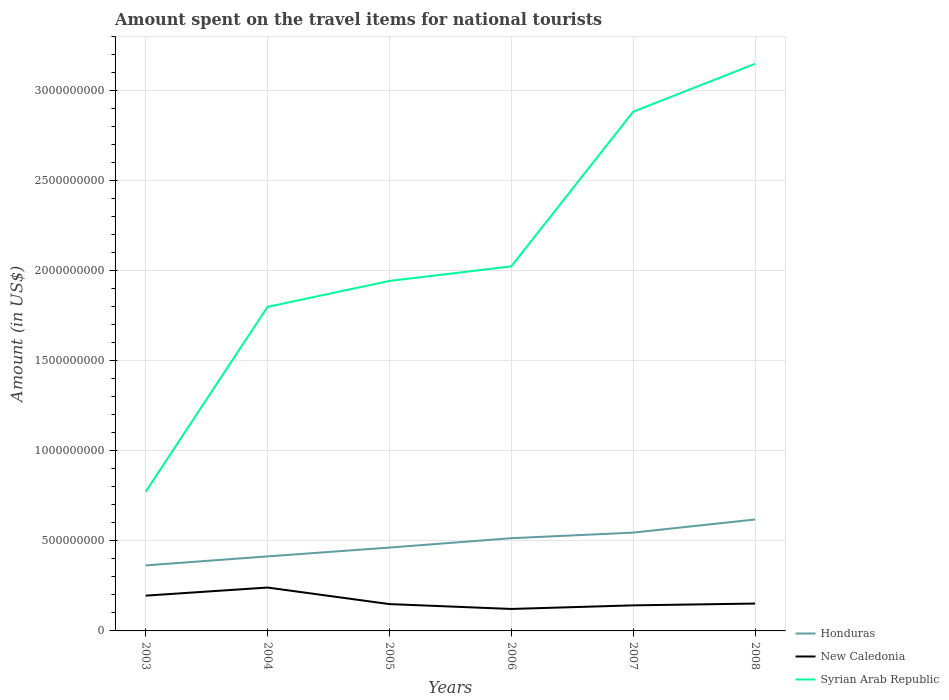Does the line corresponding to Syrian Arab Republic intersect with the line corresponding to Honduras?
Make the answer very short. No. Across all years, what is the maximum amount spent on the travel items for national tourists in Syrian Arab Republic?
Your answer should be very brief. 7.73e+08. What is the total amount spent on the travel items for national tourists in Syrian Arab Republic in the graph?
Provide a succinct answer. -1.44e+08. What is the difference between the highest and the second highest amount spent on the travel items for national tourists in New Caledonia?
Provide a short and direct response. 1.19e+08. What is the difference between the highest and the lowest amount spent on the travel items for national tourists in Syrian Arab Republic?
Your response must be concise. 2. How many years are there in the graph?
Your answer should be compact. 6. Where does the legend appear in the graph?
Offer a very short reply. Bottom right. How are the legend labels stacked?
Make the answer very short. Vertical. What is the title of the graph?
Offer a very short reply. Amount spent on the travel items for national tourists. What is the label or title of the Y-axis?
Provide a short and direct response. Amount (in US$). What is the Amount (in US$) in Honduras in 2003?
Give a very brief answer. 3.64e+08. What is the Amount (in US$) in New Caledonia in 2003?
Offer a very short reply. 1.96e+08. What is the Amount (in US$) in Syrian Arab Republic in 2003?
Give a very brief answer. 7.73e+08. What is the Amount (in US$) in Honduras in 2004?
Keep it short and to the point. 4.14e+08. What is the Amount (in US$) of New Caledonia in 2004?
Provide a short and direct response. 2.41e+08. What is the Amount (in US$) of Syrian Arab Republic in 2004?
Offer a very short reply. 1.80e+09. What is the Amount (in US$) in Honduras in 2005?
Your response must be concise. 4.63e+08. What is the Amount (in US$) in New Caledonia in 2005?
Provide a succinct answer. 1.49e+08. What is the Amount (in US$) in Syrian Arab Republic in 2005?
Provide a succinct answer. 1.94e+09. What is the Amount (in US$) of Honduras in 2006?
Make the answer very short. 5.15e+08. What is the Amount (in US$) in New Caledonia in 2006?
Your response must be concise. 1.22e+08. What is the Amount (in US$) of Syrian Arab Republic in 2006?
Your answer should be compact. 2.02e+09. What is the Amount (in US$) in Honduras in 2007?
Offer a very short reply. 5.46e+08. What is the Amount (in US$) in New Caledonia in 2007?
Ensure brevity in your answer.  1.42e+08. What is the Amount (in US$) of Syrian Arab Republic in 2007?
Give a very brief answer. 2.88e+09. What is the Amount (in US$) of Honduras in 2008?
Offer a very short reply. 6.19e+08. What is the Amount (in US$) in New Caledonia in 2008?
Provide a succinct answer. 1.52e+08. What is the Amount (in US$) in Syrian Arab Republic in 2008?
Keep it short and to the point. 3.15e+09. Across all years, what is the maximum Amount (in US$) in Honduras?
Keep it short and to the point. 6.19e+08. Across all years, what is the maximum Amount (in US$) of New Caledonia?
Keep it short and to the point. 2.41e+08. Across all years, what is the maximum Amount (in US$) of Syrian Arab Republic?
Keep it short and to the point. 3.15e+09. Across all years, what is the minimum Amount (in US$) of Honduras?
Your response must be concise. 3.64e+08. Across all years, what is the minimum Amount (in US$) of New Caledonia?
Make the answer very short. 1.22e+08. Across all years, what is the minimum Amount (in US$) in Syrian Arab Republic?
Your response must be concise. 7.73e+08. What is the total Amount (in US$) in Honduras in the graph?
Ensure brevity in your answer.  2.92e+09. What is the total Amount (in US$) of New Caledonia in the graph?
Give a very brief answer. 1.00e+09. What is the total Amount (in US$) of Syrian Arab Republic in the graph?
Offer a very short reply. 1.26e+1. What is the difference between the Amount (in US$) in Honduras in 2003 and that in 2004?
Make the answer very short. -5.00e+07. What is the difference between the Amount (in US$) in New Caledonia in 2003 and that in 2004?
Offer a terse response. -4.50e+07. What is the difference between the Amount (in US$) in Syrian Arab Republic in 2003 and that in 2004?
Make the answer very short. -1.03e+09. What is the difference between the Amount (in US$) in Honduras in 2003 and that in 2005?
Your answer should be compact. -9.90e+07. What is the difference between the Amount (in US$) in New Caledonia in 2003 and that in 2005?
Ensure brevity in your answer.  4.70e+07. What is the difference between the Amount (in US$) of Syrian Arab Republic in 2003 and that in 2005?
Give a very brief answer. -1.17e+09. What is the difference between the Amount (in US$) of Honduras in 2003 and that in 2006?
Make the answer very short. -1.51e+08. What is the difference between the Amount (in US$) in New Caledonia in 2003 and that in 2006?
Your answer should be compact. 7.40e+07. What is the difference between the Amount (in US$) of Syrian Arab Republic in 2003 and that in 2006?
Provide a succinct answer. -1.25e+09. What is the difference between the Amount (in US$) in Honduras in 2003 and that in 2007?
Ensure brevity in your answer.  -1.82e+08. What is the difference between the Amount (in US$) in New Caledonia in 2003 and that in 2007?
Your response must be concise. 5.40e+07. What is the difference between the Amount (in US$) in Syrian Arab Republic in 2003 and that in 2007?
Give a very brief answer. -2.11e+09. What is the difference between the Amount (in US$) of Honduras in 2003 and that in 2008?
Provide a short and direct response. -2.55e+08. What is the difference between the Amount (in US$) in New Caledonia in 2003 and that in 2008?
Your answer should be very brief. 4.40e+07. What is the difference between the Amount (in US$) in Syrian Arab Republic in 2003 and that in 2008?
Keep it short and to the point. -2.38e+09. What is the difference between the Amount (in US$) of Honduras in 2004 and that in 2005?
Ensure brevity in your answer.  -4.90e+07. What is the difference between the Amount (in US$) of New Caledonia in 2004 and that in 2005?
Your answer should be very brief. 9.20e+07. What is the difference between the Amount (in US$) of Syrian Arab Republic in 2004 and that in 2005?
Keep it short and to the point. -1.44e+08. What is the difference between the Amount (in US$) in Honduras in 2004 and that in 2006?
Your answer should be compact. -1.01e+08. What is the difference between the Amount (in US$) of New Caledonia in 2004 and that in 2006?
Offer a terse response. 1.19e+08. What is the difference between the Amount (in US$) in Syrian Arab Republic in 2004 and that in 2006?
Offer a very short reply. -2.25e+08. What is the difference between the Amount (in US$) of Honduras in 2004 and that in 2007?
Give a very brief answer. -1.32e+08. What is the difference between the Amount (in US$) of New Caledonia in 2004 and that in 2007?
Ensure brevity in your answer.  9.90e+07. What is the difference between the Amount (in US$) of Syrian Arab Republic in 2004 and that in 2007?
Ensure brevity in your answer.  -1.08e+09. What is the difference between the Amount (in US$) of Honduras in 2004 and that in 2008?
Offer a very short reply. -2.05e+08. What is the difference between the Amount (in US$) in New Caledonia in 2004 and that in 2008?
Your response must be concise. 8.90e+07. What is the difference between the Amount (in US$) of Syrian Arab Republic in 2004 and that in 2008?
Your answer should be very brief. -1.35e+09. What is the difference between the Amount (in US$) of Honduras in 2005 and that in 2006?
Your answer should be very brief. -5.20e+07. What is the difference between the Amount (in US$) of New Caledonia in 2005 and that in 2006?
Provide a short and direct response. 2.70e+07. What is the difference between the Amount (in US$) in Syrian Arab Republic in 2005 and that in 2006?
Your answer should be very brief. -8.10e+07. What is the difference between the Amount (in US$) in Honduras in 2005 and that in 2007?
Give a very brief answer. -8.30e+07. What is the difference between the Amount (in US$) of Syrian Arab Republic in 2005 and that in 2007?
Offer a terse response. -9.40e+08. What is the difference between the Amount (in US$) of Honduras in 2005 and that in 2008?
Provide a succinct answer. -1.56e+08. What is the difference between the Amount (in US$) in Syrian Arab Republic in 2005 and that in 2008?
Keep it short and to the point. -1.21e+09. What is the difference between the Amount (in US$) of Honduras in 2006 and that in 2007?
Offer a terse response. -3.10e+07. What is the difference between the Amount (in US$) of New Caledonia in 2006 and that in 2007?
Your answer should be very brief. -2.00e+07. What is the difference between the Amount (in US$) in Syrian Arab Republic in 2006 and that in 2007?
Make the answer very short. -8.59e+08. What is the difference between the Amount (in US$) in Honduras in 2006 and that in 2008?
Make the answer very short. -1.04e+08. What is the difference between the Amount (in US$) of New Caledonia in 2006 and that in 2008?
Offer a terse response. -3.00e+07. What is the difference between the Amount (in US$) of Syrian Arab Republic in 2006 and that in 2008?
Provide a succinct answer. -1.12e+09. What is the difference between the Amount (in US$) in Honduras in 2007 and that in 2008?
Give a very brief answer. -7.30e+07. What is the difference between the Amount (in US$) of New Caledonia in 2007 and that in 2008?
Offer a terse response. -1.00e+07. What is the difference between the Amount (in US$) in Syrian Arab Republic in 2007 and that in 2008?
Ensure brevity in your answer.  -2.66e+08. What is the difference between the Amount (in US$) of Honduras in 2003 and the Amount (in US$) of New Caledonia in 2004?
Your response must be concise. 1.23e+08. What is the difference between the Amount (in US$) in Honduras in 2003 and the Amount (in US$) in Syrian Arab Republic in 2004?
Ensure brevity in your answer.  -1.44e+09. What is the difference between the Amount (in US$) in New Caledonia in 2003 and the Amount (in US$) in Syrian Arab Republic in 2004?
Make the answer very short. -1.60e+09. What is the difference between the Amount (in US$) of Honduras in 2003 and the Amount (in US$) of New Caledonia in 2005?
Offer a terse response. 2.15e+08. What is the difference between the Amount (in US$) of Honduras in 2003 and the Amount (in US$) of Syrian Arab Republic in 2005?
Give a very brief answer. -1.58e+09. What is the difference between the Amount (in US$) in New Caledonia in 2003 and the Amount (in US$) in Syrian Arab Republic in 2005?
Make the answer very short. -1.75e+09. What is the difference between the Amount (in US$) in Honduras in 2003 and the Amount (in US$) in New Caledonia in 2006?
Your answer should be compact. 2.42e+08. What is the difference between the Amount (in US$) in Honduras in 2003 and the Amount (in US$) in Syrian Arab Republic in 2006?
Provide a succinct answer. -1.66e+09. What is the difference between the Amount (in US$) in New Caledonia in 2003 and the Amount (in US$) in Syrian Arab Republic in 2006?
Your answer should be compact. -1.83e+09. What is the difference between the Amount (in US$) in Honduras in 2003 and the Amount (in US$) in New Caledonia in 2007?
Offer a terse response. 2.22e+08. What is the difference between the Amount (in US$) of Honduras in 2003 and the Amount (in US$) of Syrian Arab Republic in 2007?
Offer a terse response. -2.52e+09. What is the difference between the Amount (in US$) in New Caledonia in 2003 and the Amount (in US$) in Syrian Arab Republic in 2007?
Give a very brief answer. -2.69e+09. What is the difference between the Amount (in US$) in Honduras in 2003 and the Amount (in US$) in New Caledonia in 2008?
Your answer should be compact. 2.12e+08. What is the difference between the Amount (in US$) in Honduras in 2003 and the Amount (in US$) in Syrian Arab Republic in 2008?
Keep it short and to the point. -2.79e+09. What is the difference between the Amount (in US$) in New Caledonia in 2003 and the Amount (in US$) in Syrian Arab Republic in 2008?
Provide a short and direct response. -2.95e+09. What is the difference between the Amount (in US$) of Honduras in 2004 and the Amount (in US$) of New Caledonia in 2005?
Provide a succinct answer. 2.65e+08. What is the difference between the Amount (in US$) in Honduras in 2004 and the Amount (in US$) in Syrian Arab Republic in 2005?
Your answer should be compact. -1.53e+09. What is the difference between the Amount (in US$) in New Caledonia in 2004 and the Amount (in US$) in Syrian Arab Republic in 2005?
Your response must be concise. -1.70e+09. What is the difference between the Amount (in US$) of Honduras in 2004 and the Amount (in US$) of New Caledonia in 2006?
Your response must be concise. 2.92e+08. What is the difference between the Amount (in US$) in Honduras in 2004 and the Amount (in US$) in Syrian Arab Republic in 2006?
Ensure brevity in your answer.  -1.61e+09. What is the difference between the Amount (in US$) of New Caledonia in 2004 and the Amount (in US$) of Syrian Arab Republic in 2006?
Provide a short and direct response. -1.78e+09. What is the difference between the Amount (in US$) of Honduras in 2004 and the Amount (in US$) of New Caledonia in 2007?
Make the answer very short. 2.72e+08. What is the difference between the Amount (in US$) of Honduras in 2004 and the Amount (in US$) of Syrian Arab Republic in 2007?
Your response must be concise. -2.47e+09. What is the difference between the Amount (in US$) in New Caledonia in 2004 and the Amount (in US$) in Syrian Arab Republic in 2007?
Your answer should be very brief. -2.64e+09. What is the difference between the Amount (in US$) of Honduras in 2004 and the Amount (in US$) of New Caledonia in 2008?
Provide a short and direct response. 2.62e+08. What is the difference between the Amount (in US$) in Honduras in 2004 and the Amount (in US$) in Syrian Arab Republic in 2008?
Your answer should be very brief. -2.74e+09. What is the difference between the Amount (in US$) in New Caledonia in 2004 and the Amount (in US$) in Syrian Arab Republic in 2008?
Give a very brief answer. -2.91e+09. What is the difference between the Amount (in US$) in Honduras in 2005 and the Amount (in US$) in New Caledonia in 2006?
Ensure brevity in your answer.  3.41e+08. What is the difference between the Amount (in US$) in Honduras in 2005 and the Amount (in US$) in Syrian Arab Republic in 2006?
Give a very brief answer. -1.56e+09. What is the difference between the Amount (in US$) of New Caledonia in 2005 and the Amount (in US$) of Syrian Arab Republic in 2006?
Provide a succinct answer. -1.88e+09. What is the difference between the Amount (in US$) of Honduras in 2005 and the Amount (in US$) of New Caledonia in 2007?
Make the answer very short. 3.21e+08. What is the difference between the Amount (in US$) of Honduras in 2005 and the Amount (in US$) of Syrian Arab Republic in 2007?
Your answer should be very brief. -2.42e+09. What is the difference between the Amount (in US$) in New Caledonia in 2005 and the Amount (in US$) in Syrian Arab Republic in 2007?
Keep it short and to the point. -2.74e+09. What is the difference between the Amount (in US$) of Honduras in 2005 and the Amount (in US$) of New Caledonia in 2008?
Provide a succinct answer. 3.11e+08. What is the difference between the Amount (in US$) of Honduras in 2005 and the Amount (in US$) of Syrian Arab Republic in 2008?
Your answer should be compact. -2.69e+09. What is the difference between the Amount (in US$) in New Caledonia in 2005 and the Amount (in US$) in Syrian Arab Republic in 2008?
Provide a succinct answer. -3.00e+09. What is the difference between the Amount (in US$) of Honduras in 2006 and the Amount (in US$) of New Caledonia in 2007?
Your answer should be very brief. 3.73e+08. What is the difference between the Amount (in US$) of Honduras in 2006 and the Amount (in US$) of Syrian Arab Republic in 2007?
Offer a terse response. -2.37e+09. What is the difference between the Amount (in US$) of New Caledonia in 2006 and the Amount (in US$) of Syrian Arab Republic in 2007?
Your answer should be compact. -2.76e+09. What is the difference between the Amount (in US$) in Honduras in 2006 and the Amount (in US$) in New Caledonia in 2008?
Keep it short and to the point. 3.63e+08. What is the difference between the Amount (in US$) in Honduras in 2006 and the Amount (in US$) in Syrian Arab Republic in 2008?
Your response must be concise. -2.64e+09. What is the difference between the Amount (in US$) of New Caledonia in 2006 and the Amount (in US$) of Syrian Arab Republic in 2008?
Offer a terse response. -3.03e+09. What is the difference between the Amount (in US$) of Honduras in 2007 and the Amount (in US$) of New Caledonia in 2008?
Make the answer very short. 3.94e+08. What is the difference between the Amount (in US$) of Honduras in 2007 and the Amount (in US$) of Syrian Arab Republic in 2008?
Your response must be concise. -2.60e+09. What is the difference between the Amount (in US$) of New Caledonia in 2007 and the Amount (in US$) of Syrian Arab Republic in 2008?
Make the answer very short. -3.01e+09. What is the average Amount (in US$) of Honduras per year?
Make the answer very short. 4.87e+08. What is the average Amount (in US$) in New Caledonia per year?
Provide a short and direct response. 1.67e+08. What is the average Amount (in US$) in Syrian Arab Republic per year?
Provide a succinct answer. 2.10e+09. In the year 2003, what is the difference between the Amount (in US$) of Honduras and Amount (in US$) of New Caledonia?
Offer a terse response. 1.68e+08. In the year 2003, what is the difference between the Amount (in US$) in Honduras and Amount (in US$) in Syrian Arab Republic?
Make the answer very short. -4.09e+08. In the year 2003, what is the difference between the Amount (in US$) of New Caledonia and Amount (in US$) of Syrian Arab Republic?
Ensure brevity in your answer.  -5.77e+08. In the year 2004, what is the difference between the Amount (in US$) of Honduras and Amount (in US$) of New Caledonia?
Keep it short and to the point. 1.73e+08. In the year 2004, what is the difference between the Amount (in US$) in Honduras and Amount (in US$) in Syrian Arab Republic?
Provide a succinct answer. -1.39e+09. In the year 2004, what is the difference between the Amount (in US$) in New Caledonia and Amount (in US$) in Syrian Arab Republic?
Your answer should be very brief. -1.56e+09. In the year 2005, what is the difference between the Amount (in US$) of Honduras and Amount (in US$) of New Caledonia?
Your response must be concise. 3.14e+08. In the year 2005, what is the difference between the Amount (in US$) of Honduras and Amount (in US$) of Syrian Arab Republic?
Ensure brevity in your answer.  -1.48e+09. In the year 2005, what is the difference between the Amount (in US$) of New Caledonia and Amount (in US$) of Syrian Arab Republic?
Keep it short and to the point. -1.80e+09. In the year 2006, what is the difference between the Amount (in US$) of Honduras and Amount (in US$) of New Caledonia?
Your response must be concise. 3.93e+08. In the year 2006, what is the difference between the Amount (in US$) in Honduras and Amount (in US$) in Syrian Arab Republic?
Ensure brevity in your answer.  -1.51e+09. In the year 2006, what is the difference between the Amount (in US$) in New Caledonia and Amount (in US$) in Syrian Arab Republic?
Your answer should be very brief. -1.90e+09. In the year 2007, what is the difference between the Amount (in US$) in Honduras and Amount (in US$) in New Caledonia?
Your response must be concise. 4.04e+08. In the year 2007, what is the difference between the Amount (in US$) of Honduras and Amount (in US$) of Syrian Arab Republic?
Provide a short and direct response. -2.34e+09. In the year 2007, what is the difference between the Amount (in US$) in New Caledonia and Amount (in US$) in Syrian Arab Republic?
Provide a succinct answer. -2.74e+09. In the year 2008, what is the difference between the Amount (in US$) in Honduras and Amount (in US$) in New Caledonia?
Your response must be concise. 4.67e+08. In the year 2008, what is the difference between the Amount (in US$) in Honduras and Amount (in US$) in Syrian Arab Republic?
Provide a succinct answer. -2.53e+09. In the year 2008, what is the difference between the Amount (in US$) in New Caledonia and Amount (in US$) in Syrian Arab Republic?
Offer a terse response. -3.00e+09. What is the ratio of the Amount (in US$) in Honduras in 2003 to that in 2004?
Make the answer very short. 0.88. What is the ratio of the Amount (in US$) of New Caledonia in 2003 to that in 2004?
Your answer should be very brief. 0.81. What is the ratio of the Amount (in US$) of Syrian Arab Republic in 2003 to that in 2004?
Offer a terse response. 0.43. What is the ratio of the Amount (in US$) in Honduras in 2003 to that in 2005?
Provide a short and direct response. 0.79. What is the ratio of the Amount (in US$) of New Caledonia in 2003 to that in 2005?
Offer a very short reply. 1.32. What is the ratio of the Amount (in US$) in Syrian Arab Republic in 2003 to that in 2005?
Ensure brevity in your answer.  0.4. What is the ratio of the Amount (in US$) of Honduras in 2003 to that in 2006?
Ensure brevity in your answer.  0.71. What is the ratio of the Amount (in US$) in New Caledonia in 2003 to that in 2006?
Make the answer very short. 1.61. What is the ratio of the Amount (in US$) in Syrian Arab Republic in 2003 to that in 2006?
Ensure brevity in your answer.  0.38. What is the ratio of the Amount (in US$) in New Caledonia in 2003 to that in 2007?
Your answer should be compact. 1.38. What is the ratio of the Amount (in US$) in Syrian Arab Republic in 2003 to that in 2007?
Give a very brief answer. 0.27. What is the ratio of the Amount (in US$) in Honduras in 2003 to that in 2008?
Offer a very short reply. 0.59. What is the ratio of the Amount (in US$) in New Caledonia in 2003 to that in 2008?
Provide a succinct answer. 1.29. What is the ratio of the Amount (in US$) of Syrian Arab Republic in 2003 to that in 2008?
Your answer should be very brief. 0.25. What is the ratio of the Amount (in US$) of Honduras in 2004 to that in 2005?
Give a very brief answer. 0.89. What is the ratio of the Amount (in US$) in New Caledonia in 2004 to that in 2005?
Make the answer very short. 1.62. What is the ratio of the Amount (in US$) in Syrian Arab Republic in 2004 to that in 2005?
Give a very brief answer. 0.93. What is the ratio of the Amount (in US$) in Honduras in 2004 to that in 2006?
Ensure brevity in your answer.  0.8. What is the ratio of the Amount (in US$) in New Caledonia in 2004 to that in 2006?
Your answer should be very brief. 1.98. What is the ratio of the Amount (in US$) of Honduras in 2004 to that in 2007?
Keep it short and to the point. 0.76. What is the ratio of the Amount (in US$) of New Caledonia in 2004 to that in 2007?
Offer a very short reply. 1.7. What is the ratio of the Amount (in US$) in Syrian Arab Republic in 2004 to that in 2007?
Your response must be concise. 0.62. What is the ratio of the Amount (in US$) of Honduras in 2004 to that in 2008?
Your answer should be very brief. 0.67. What is the ratio of the Amount (in US$) of New Caledonia in 2004 to that in 2008?
Give a very brief answer. 1.59. What is the ratio of the Amount (in US$) in Syrian Arab Republic in 2004 to that in 2008?
Provide a short and direct response. 0.57. What is the ratio of the Amount (in US$) of Honduras in 2005 to that in 2006?
Provide a succinct answer. 0.9. What is the ratio of the Amount (in US$) of New Caledonia in 2005 to that in 2006?
Your answer should be compact. 1.22. What is the ratio of the Amount (in US$) of Syrian Arab Republic in 2005 to that in 2006?
Your answer should be compact. 0.96. What is the ratio of the Amount (in US$) in Honduras in 2005 to that in 2007?
Offer a terse response. 0.85. What is the ratio of the Amount (in US$) in New Caledonia in 2005 to that in 2007?
Provide a short and direct response. 1.05. What is the ratio of the Amount (in US$) of Syrian Arab Republic in 2005 to that in 2007?
Offer a terse response. 0.67. What is the ratio of the Amount (in US$) of Honduras in 2005 to that in 2008?
Ensure brevity in your answer.  0.75. What is the ratio of the Amount (in US$) of New Caledonia in 2005 to that in 2008?
Provide a short and direct response. 0.98. What is the ratio of the Amount (in US$) of Syrian Arab Republic in 2005 to that in 2008?
Provide a succinct answer. 0.62. What is the ratio of the Amount (in US$) in Honduras in 2006 to that in 2007?
Provide a short and direct response. 0.94. What is the ratio of the Amount (in US$) of New Caledonia in 2006 to that in 2007?
Offer a terse response. 0.86. What is the ratio of the Amount (in US$) of Syrian Arab Republic in 2006 to that in 2007?
Your answer should be very brief. 0.7. What is the ratio of the Amount (in US$) of Honduras in 2006 to that in 2008?
Provide a short and direct response. 0.83. What is the ratio of the Amount (in US$) of New Caledonia in 2006 to that in 2008?
Offer a terse response. 0.8. What is the ratio of the Amount (in US$) of Syrian Arab Republic in 2006 to that in 2008?
Your answer should be very brief. 0.64. What is the ratio of the Amount (in US$) of Honduras in 2007 to that in 2008?
Provide a succinct answer. 0.88. What is the ratio of the Amount (in US$) of New Caledonia in 2007 to that in 2008?
Offer a terse response. 0.93. What is the ratio of the Amount (in US$) of Syrian Arab Republic in 2007 to that in 2008?
Provide a succinct answer. 0.92. What is the difference between the highest and the second highest Amount (in US$) of Honduras?
Keep it short and to the point. 7.30e+07. What is the difference between the highest and the second highest Amount (in US$) of New Caledonia?
Your answer should be very brief. 4.50e+07. What is the difference between the highest and the second highest Amount (in US$) in Syrian Arab Republic?
Your response must be concise. 2.66e+08. What is the difference between the highest and the lowest Amount (in US$) of Honduras?
Offer a very short reply. 2.55e+08. What is the difference between the highest and the lowest Amount (in US$) in New Caledonia?
Your answer should be compact. 1.19e+08. What is the difference between the highest and the lowest Amount (in US$) of Syrian Arab Republic?
Keep it short and to the point. 2.38e+09. 